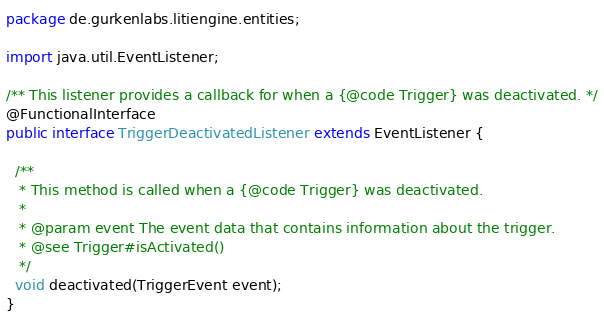<code> <loc_0><loc_0><loc_500><loc_500><_Java_>package de.gurkenlabs.litiengine.entities;

import java.util.EventListener;

/** This listener provides a callback for when a {@code Trigger} was deactivated. */
@FunctionalInterface
public interface TriggerDeactivatedListener extends EventListener {

  /**
   * This method is called when a {@code Trigger} was deactivated.
   *
   * @param event The event data that contains information about the trigger.
   * @see Trigger#isActivated()
   */
  void deactivated(TriggerEvent event);
}
</code> 